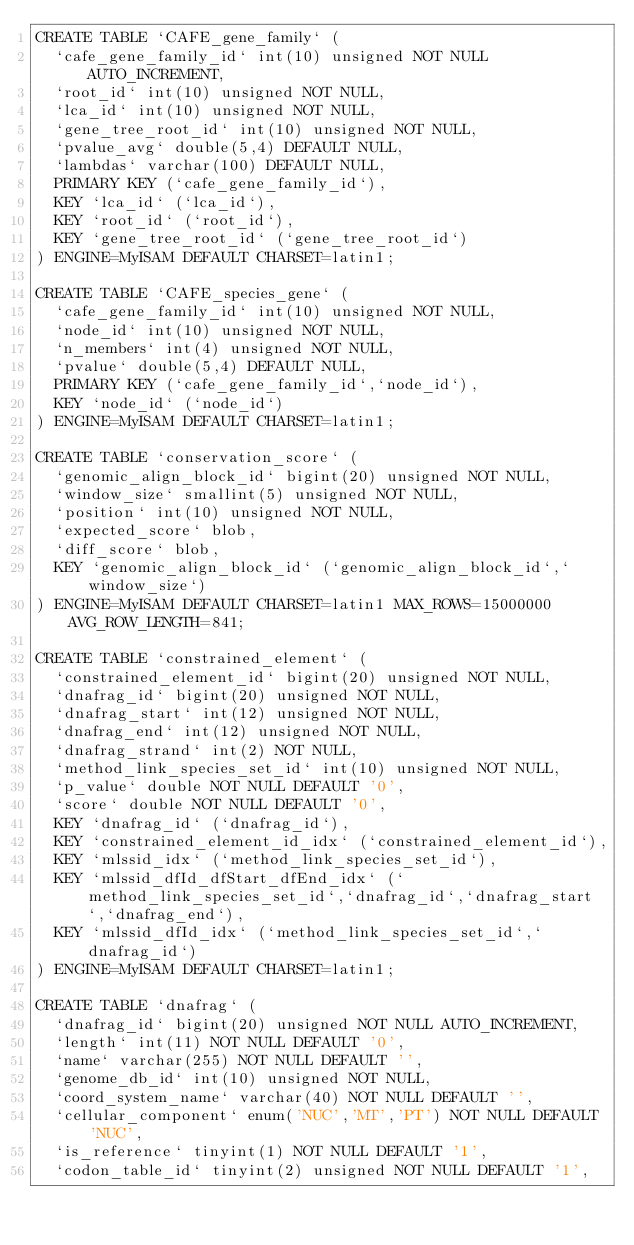Convert code to text. <code><loc_0><loc_0><loc_500><loc_500><_SQL_>CREATE TABLE `CAFE_gene_family` (
  `cafe_gene_family_id` int(10) unsigned NOT NULL AUTO_INCREMENT,
  `root_id` int(10) unsigned NOT NULL,
  `lca_id` int(10) unsigned NOT NULL,
  `gene_tree_root_id` int(10) unsigned NOT NULL,
  `pvalue_avg` double(5,4) DEFAULT NULL,
  `lambdas` varchar(100) DEFAULT NULL,
  PRIMARY KEY (`cafe_gene_family_id`),
  KEY `lca_id` (`lca_id`),
  KEY `root_id` (`root_id`),
  KEY `gene_tree_root_id` (`gene_tree_root_id`)
) ENGINE=MyISAM DEFAULT CHARSET=latin1;

CREATE TABLE `CAFE_species_gene` (
  `cafe_gene_family_id` int(10) unsigned NOT NULL,
  `node_id` int(10) unsigned NOT NULL,
  `n_members` int(4) unsigned NOT NULL,
  `pvalue` double(5,4) DEFAULT NULL,
  PRIMARY KEY (`cafe_gene_family_id`,`node_id`),
  KEY `node_id` (`node_id`)
) ENGINE=MyISAM DEFAULT CHARSET=latin1;

CREATE TABLE `conservation_score` (
  `genomic_align_block_id` bigint(20) unsigned NOT NULL,
  `window_size` smallint(5) unsigned NOT NULL,
  `position` int(10) unsigned NOT NULL,
  `expected_score` blob,
  `diff_score` blob,
  KEY `genomic_align_block_id` (`genomic_align_block_id`,`window_size`)
) ENGINE=MyISAM DEFAULT CHARSET=latin1 MAX_ROWS=15000000 AVG_ROW_LENGTH=841;

CREATE TABLE `constrained_element` (
  `constrained_element_id` bigint(20) unsigned NOT NULL,
  `dnafrag_id` bigint(20) unsigned NOT NULL,
  `dnafrag_start` int(12) unsigned NOT NULL,
  `dnafrag_end` int(12) unsigned NOT NULL,
  `dnafrag_strand` int(2) NOT NULL,
  `method_link_species_set_id` int(10) unsigned NOT NULL,
  `p_value` double NOT NULL DEFAULT '0',
  `score` double NOT NULL DEFAULT '0',
  KEY `dnafrag_id` (`dnafrag_id`),
  KEY `constrained_element_id_idx` (`constrained_element_id`),
  KEY `mlssid_idx` (`method_link_species_set_id`),
  KEY `mlssid_dfId_dfStart_dfEnd_idx` (`method_link_species_set_id`,`dnafrag_id`,`dnafrag_start`,`dnafrag_end`),
  KEY `mlssid_dfId_idx` (`method_link_species_set_id`,`dnafrag_id`)
) ENGINE=MyISAM DEFAULT CHARSET=latin1;

CREATE TABLE `dnafrag` (
  `dnafrag_id` bigint(20) unsigned NOT NULL AUTO_INCREMENT,
  `length` int(11) NOT NULL DEFAULT '0',
  `name` varchar(255) NOT NULL DEFAULT '',
  `genome_db_id` int(10) unsigned NOT NULL,
  `coord_system_name` varchar(40) NOT NULL DEFAULT '',
  `cellular_component` enum('NUC','MT','PT') NOT NULL DEFAULT 'NUC',
  `is_reference` tinyint(1) NOT NULL DEFAULT '1',
  `codon_table_id` tinyint(2) unsigned NOT NULL DEFAULT '1',</code> 